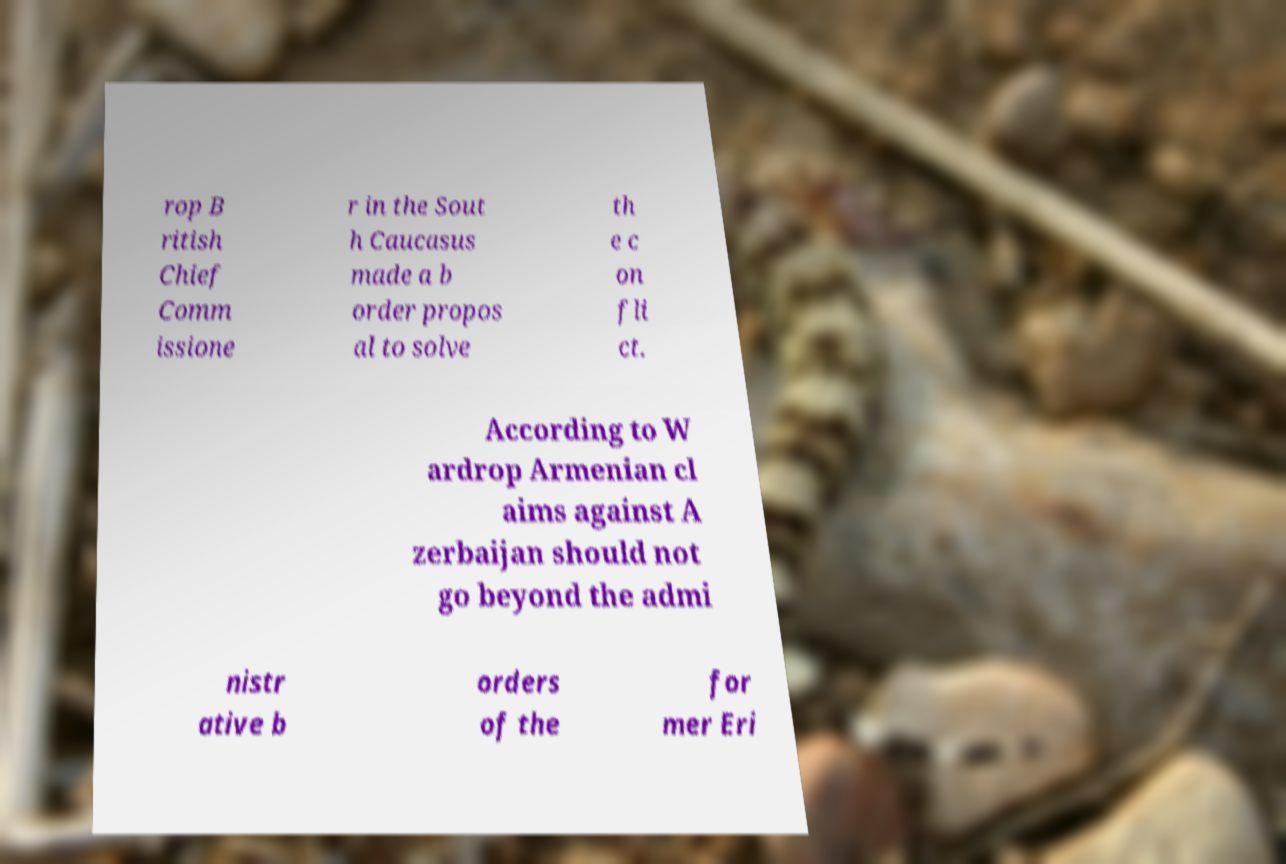I need the written content from this picture converted into text. Can you do that? rop B ritish Chief Comm issione r in the Sout h Caucasus made a b order propos al to solve th e c on fli ct. According to W ardrop Armenian cl aims against A zerbaijan should not go beyond the admi nistr ative b orders of the for mer Eri 